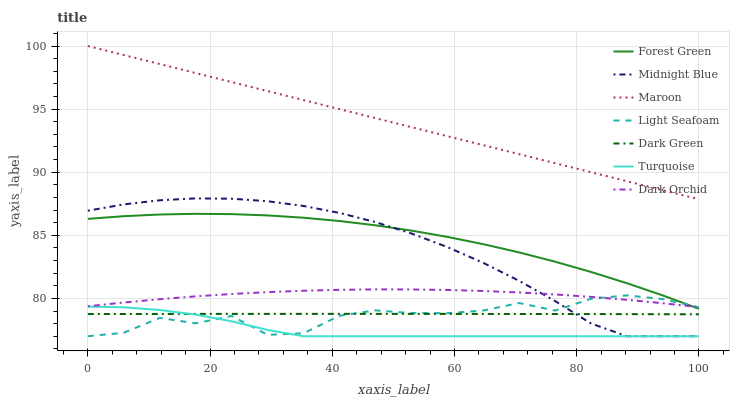Does Turquoise have the minimum area under the curve?
Answer yes or no. Yes. Does Maroon have the maximum area under the curve?
Answer yes or no. Yes. Does Midnight Blue have the minimum area under the curve?
Answer yes or no. No. Does Midnight Blue have the maximum area under the curve?
Answer yes or no. No. Is Maroon the smoothest?
Answer yes or no. Yes. Is Light Seafoam the roughest?
Answer yes or no. Yes. Is Midnight Blue the smoothest?
Answer yes or no. No. Is Midnight Blue the roughest?
Answer yes or no. No. Does Turquoise have the lowest value?
Answer yes or no. Yes. Does Maroon have the lowest value?
Answer yes or no. No. Does Maroon have the highest value?
Answer yes or no. Yes. Does Midnight Blue have the highest value?
Answer yes or no. No. Is Dark Orchid less than Maroon?
Answer yes or no. Yes. Is Dark Orchid greater than Dark Green?
Answer yes or no. Yes. Does Forest Green intersect Midnight Blue?
Answer yes or no. Yes. Is Forest Green less than Midnight Blue?
Answer yes or no. No. Is Forest Green greater than Midnight Blue?
Answer yes or no. No. Does Dark Orchid intersect Maroon?
Answer yes or no. No. 